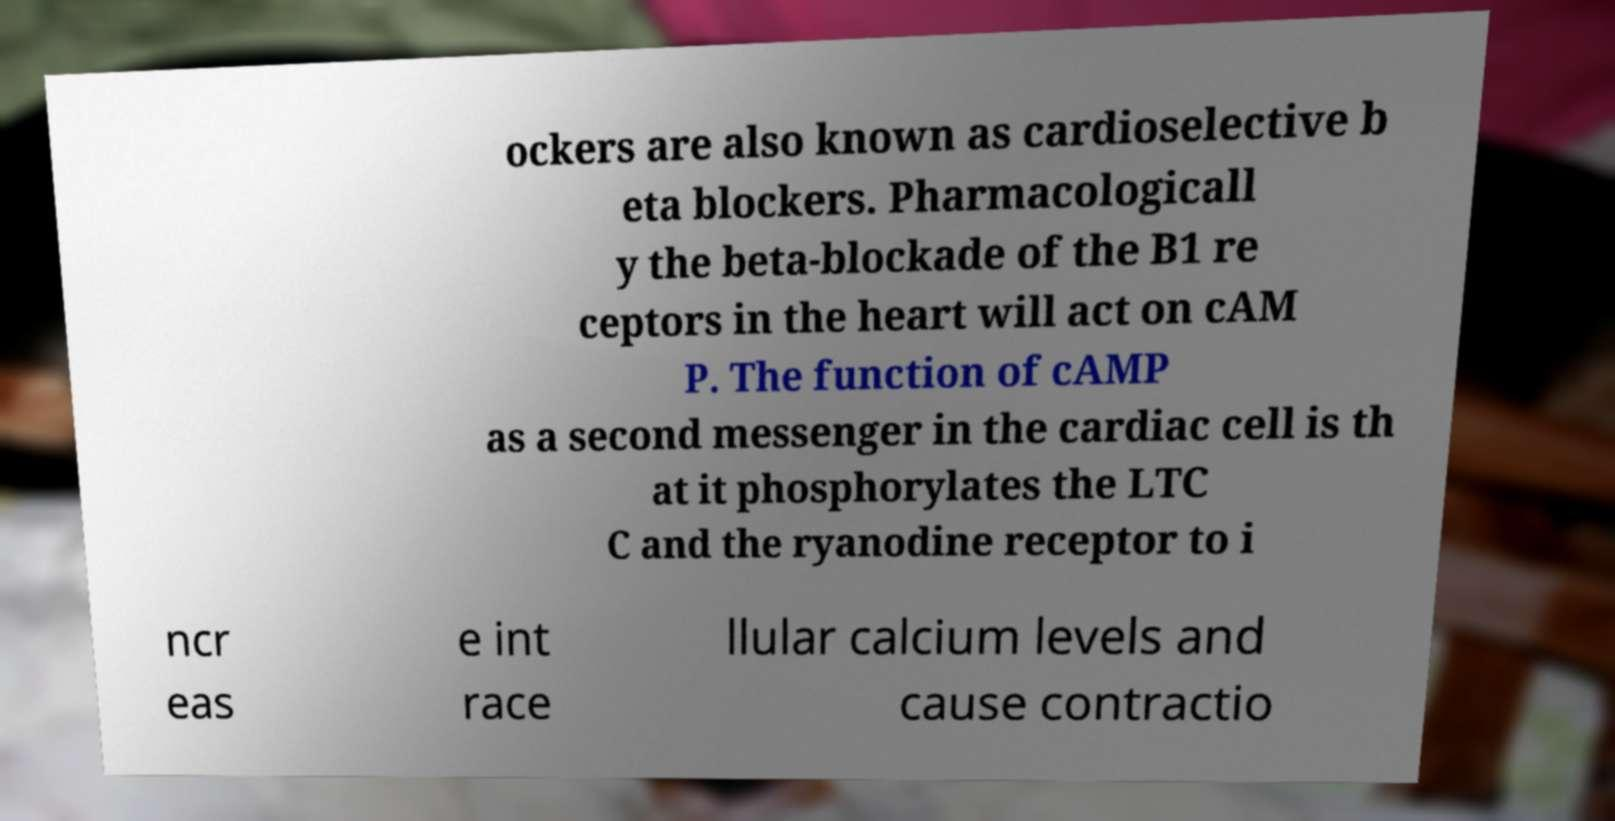There's text embedded in this image that I need extracted. Can you transcribe it verbatim? ockers are also known as cardioselective b eta blockers. Pharmacologicall y the beta-blockade of the B1 re ceptors in the heart will act on cAM P. The function of cAMP as a second messenger in the cardiac cell is th at it phosphorylates the LTC C and the ryanodine receptor to i ncr eas e int race llular calcium levels and cause contractio 